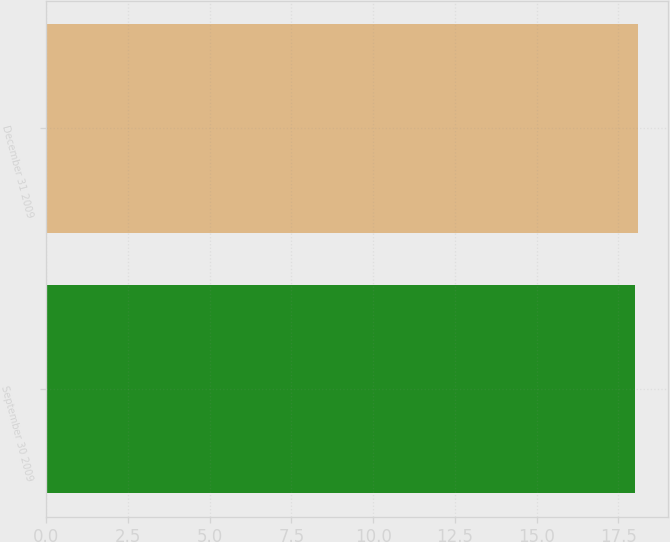Convert chart. <chart><loc_0><loc_0><loc_500><loc_500><bar_chart><fcel>September 30 2009<fcel>December 31 2009<nl><fcel>18<fcel>18.1<nl></chart> 